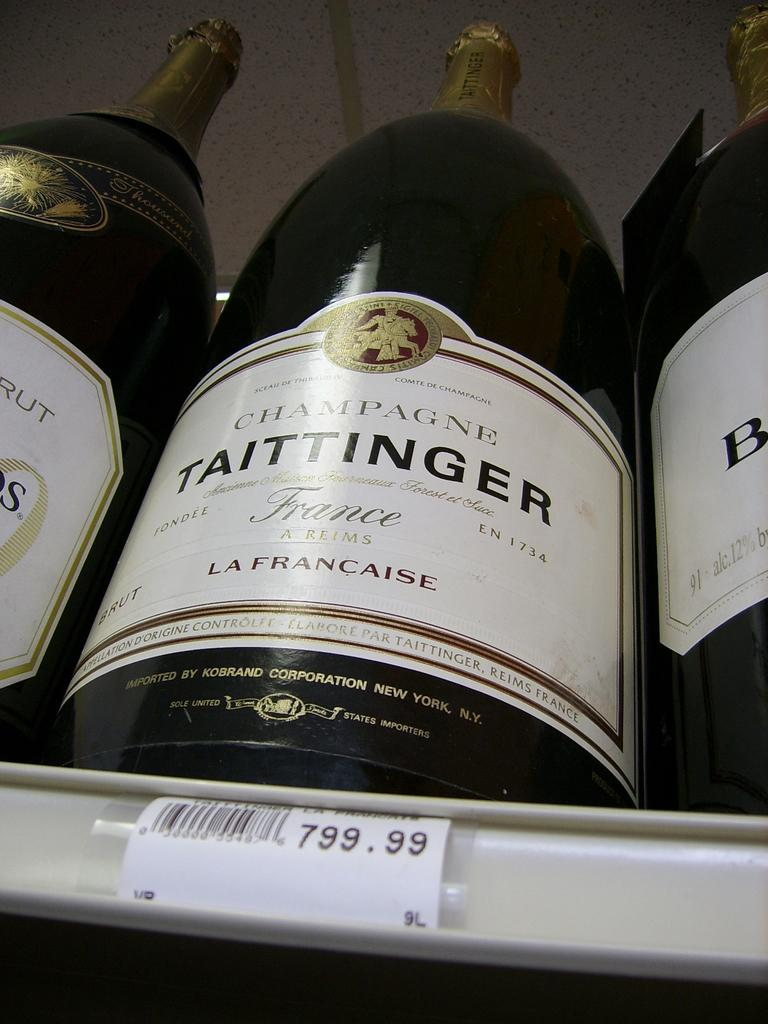<image>
Offer a succinct explanation of the picture presented. Bottles of champagne sit on a store shelf marked with a 799.99 price tag. 